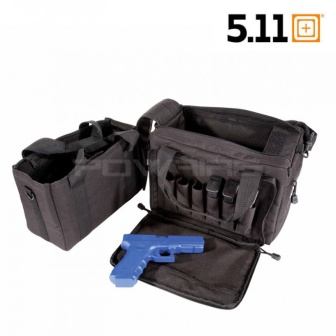How might someone customize this bag for their specific needs? Customization possibilities for this tactical bag are vast due to its modular design. Users might add velcro patches for identification or morale patches. Additional pouches or gear holders can be attached to the external webbing to tailor the bag’s functionality to specific tools or devices needed for particular activities or professional duties. Its adaptable nature allows users to transform it according to varying needs and scenarios. 